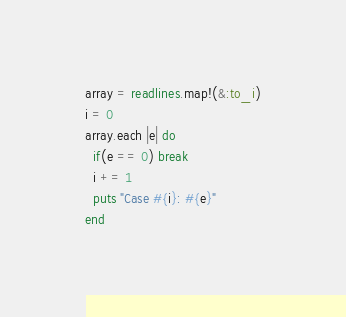<code> <loc_0><loc_0><loc_500><loc_500><_Ruby_>array = readlines.map!(&:to_i)
i = 0
array.each |e| do
  if(e == 0) break
  i += 1
  puts "Case #{i}: #{e}"
end</code> 